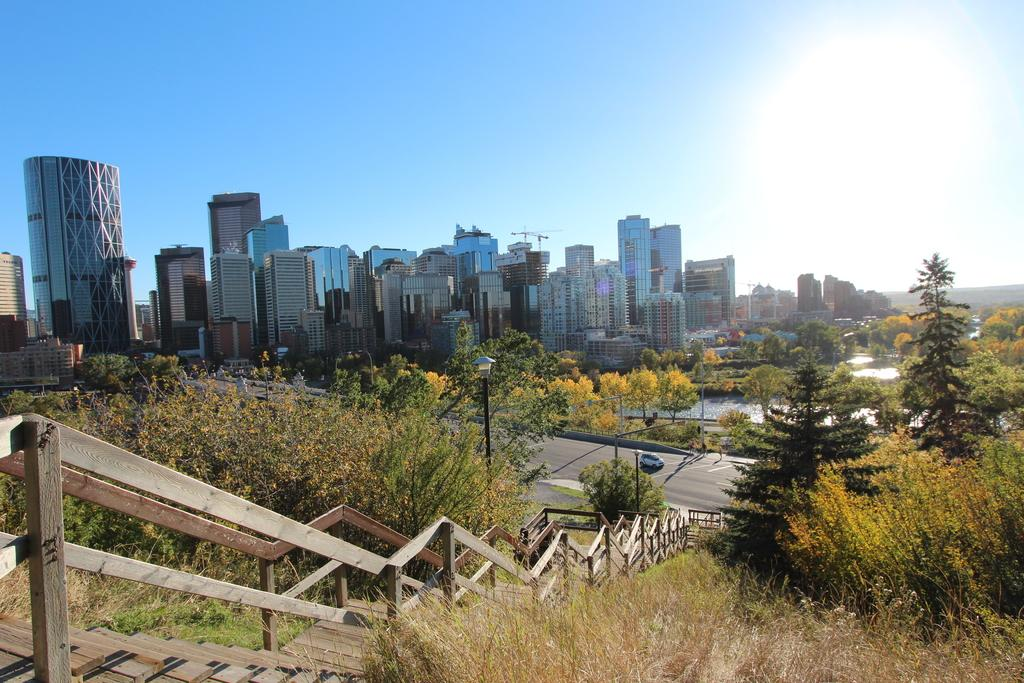What type of structure is present in the image? There are stairs, a fence, buildings, and trees in the image. Can you describe the lighting in the image? There are light poles in the image, which provide lighting. What is visible in the background of the image? The sky is visible in the image. Is there any transportation visible in the image? Yes, there is a vehicle on the road in the image. What type of ink is used to write on the fence in the image? There is no writing or ink present on the fence in the image. Can you describe the pickle that is hanging from the light pole in the image? There is no pickle present in the image; it is a light pole, not a pickle. 